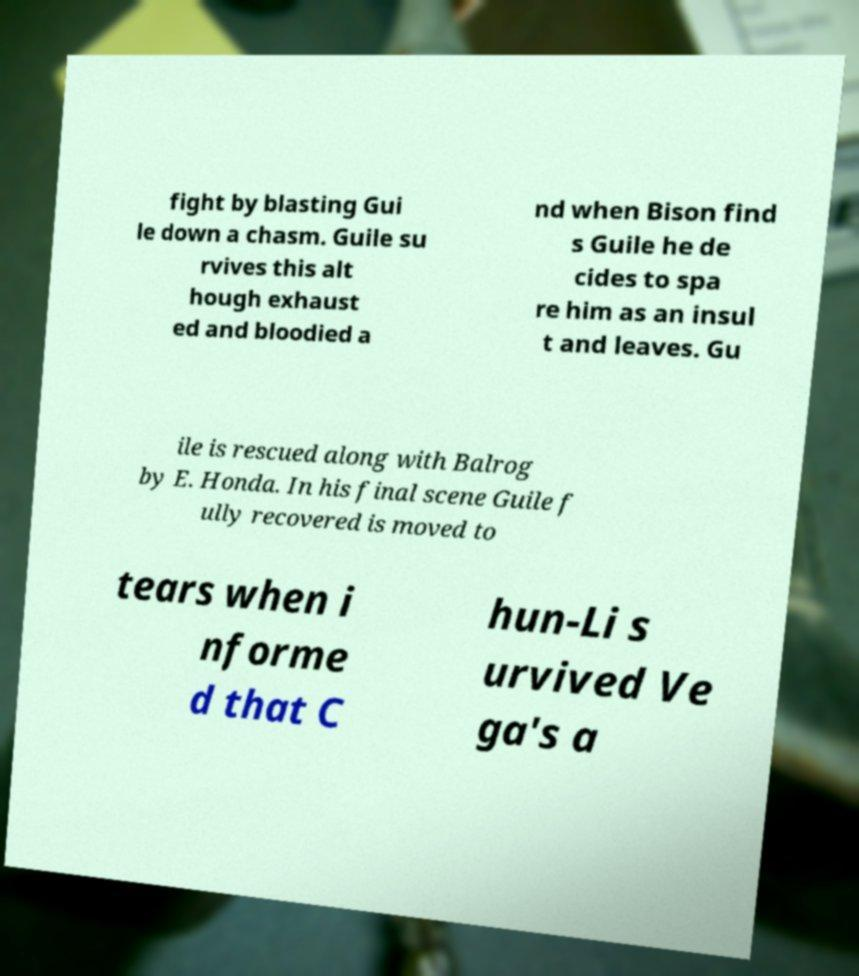Could you assist in decoding the text presented in this image and type it out clearly? fight by blasting Gui le down a chasm. Guile su rvives this alt hough exhaust ed and bloodied a nd when Bison find s Guile he de cides to spa re him as an insul t and leaves. Gu ile is rescued along with Balrog by E. Honda. In his final scene Guile f ully recovered is moved to tears when i nforme d that C hun-Li s urvived Ve ga's a 